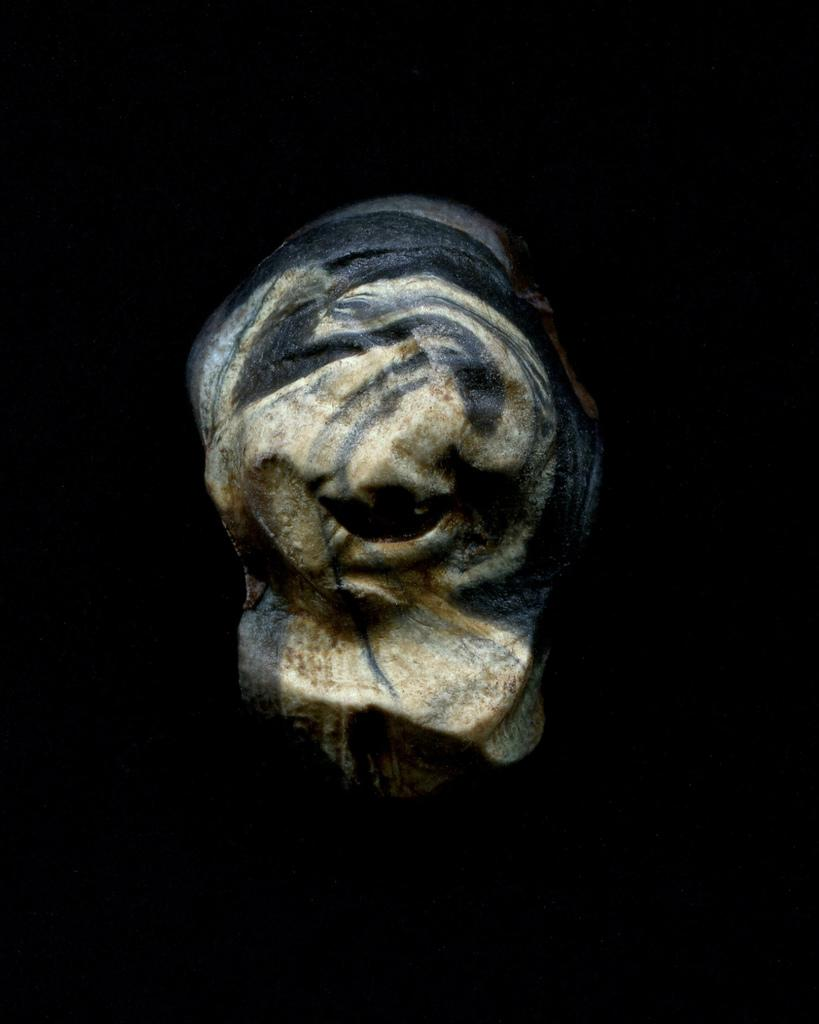What is the main subject of the image? The main subject of the image is a sculpture. Can you describe the background of the image? The background of the image is dark. What time is displayed on the clock in the image? There is no clock present in the image. What type of scissors are being used to help create the sculpture in the image? There are no scissors or indication of help in the process of creating the sculpture in the image. 